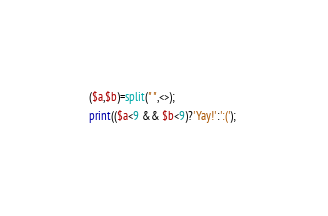Convert code to text. <code><loc_0><loc_0><loc_500><loc_500><_Perl_>($a,$b)=split(" ",<>);
print(($a<9 && $b<9)?'Yay!':':('); </code> 